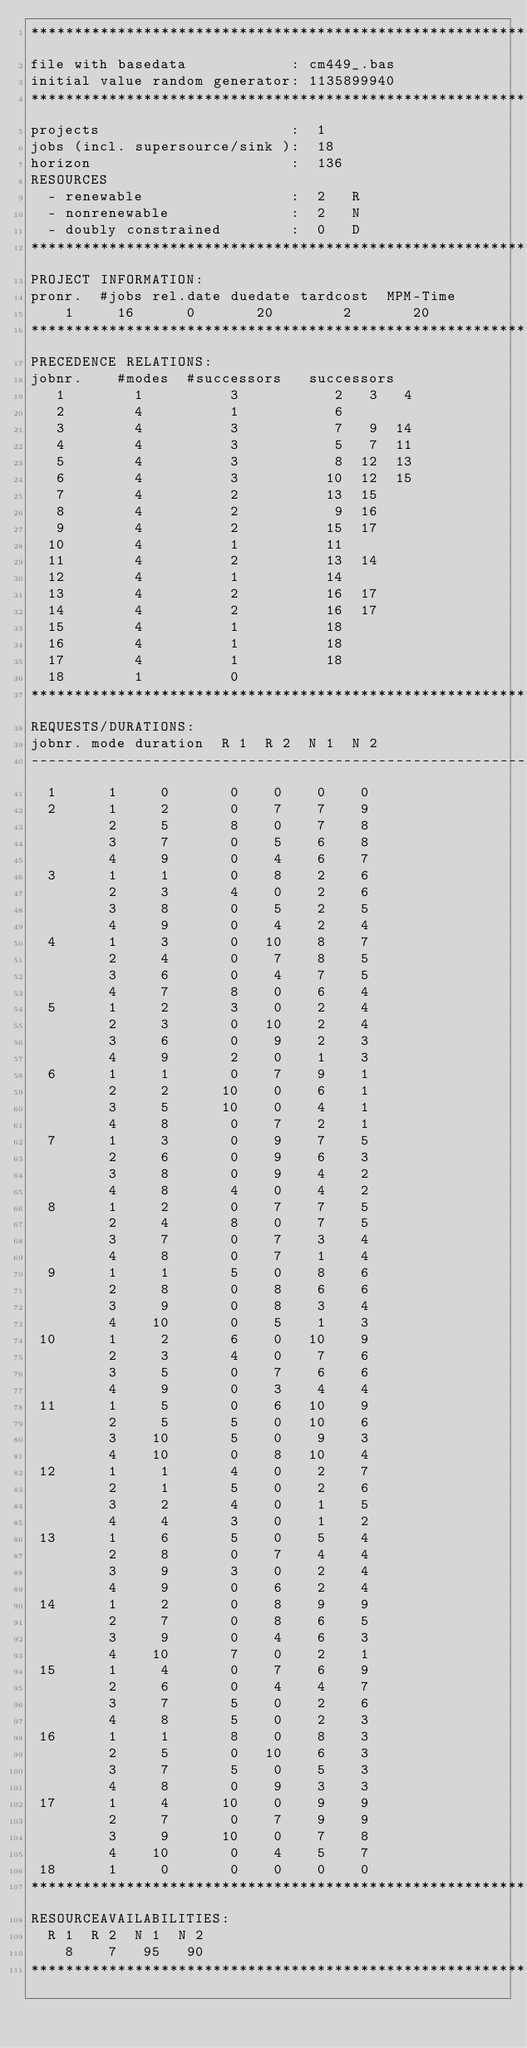Convert code to text. <code><loc_0><loc_0><loc_500><loc_500><_ObjectiveC_>************************************************************************
file with basedata            : cm449_.bas
initial value random generator: 1135899940
************************************************************************
projects                      :  1
jobs (incl. supersource/sink ):  18
horizon                       :  136
RESOURCES
  - renewable                 :  2   R
  - nonrenewable              :  2   N
  - doubly constrained        :  0   D
************************************************************************
PROJECT INFORMATION:
pronr.  #jobs rel.date duedate tardcost  MPM-Time
    1     16      0       20        2       20
************************************************************************
PRECEDENCE RELATIONS:
jobnr.    #modes  #successors   successors
   1        1          3           2   3   4
   2        4          1           6
   3        4          3           7   9  14
   4        4          3           5   7  11
   5        4          3           8  12  13
   6        4          3          10  12  15
   7        4          2          13  15
   8        4          2           9  16
   9        4          2          15  17
  10        4          1          11
  11        4          2          13  14
  12        4          1          14
  13        4          2          16  17
  14        4          2          16  17
  15        4          1          18
  16        4          1          18
  17        4          1          18
  18        1          0        
************************************************************************
REQUESTS/DURATIONS:
jobnr. mode duration  R 1  R 2  N 1  N 2
------------------------------------------------------------------------
  1      1     0       0    0    0    0
  2      1     2       0    7    7    9
         2     5       8    0    7    8
         3     7       0    5    6    8
         4     9       0    4    6    7
  3      1     1       0    8    2    6
         2     3       4    0    2    6
         3     8       0    5    2    5
         4     9       0    4    2    4
  4      1     3       0   10    8    7
         2     4       0    7    8    5
         3     6       0    4    7    5
         4     7       8    0    6    4
  5      1     2       3    0    2    4
         2     3       0   10    2    4
         3     6       0    9    2    3
         4     9       2    0    1    3
  6      1     1       0    7    9    1
         2     2      10    0    6    1
         3     5      10    0    4    1
         4     8       0    7    2    1
  7      1     3       0    9    7    5
         2     6       0    9    6    3
         3     8       0    9    4    2
         4     8       4    0    4    2
  8      1     2       0    7    7    5
         2     4       8    0    7    5
         3     7       0    7    3    4
         4     8       0    7    1    4
  9      1     1       5    0    8    6
         2     8       0    8    6    6
         3     9       0    8    3    4
         4    10       0    5    1    3
 10      1     2       6    0   10    9
         2     3       4    0    7    6
         3     5       0    7    6    6
         4     9       0    3    4    4
 11      1     5       0    6   10    9
         2     5       5    0   10    6
         3    10       5    0    9    3
         4    10       0    8   10    4
 12      1     1       4    0    2    7
         2     1       5    0    2    6
         3     2       4    0    1    5
         4     4       3    0    1    2
 13      1     6       5    0    5    4
         2     8       0    7    4    4
         3     9       3    0    2    4
         4     9       0    6    2    4
 14      1     2       0    8    9    9
         2     7       0    8    6    5
         3     9       0    4    6    3
         4    10       7    0    2    1
 15      1     4       0    7    6    9
         2     6       0    4    4    7
         3     7       5    0    2    6
         4     8       5    0    2    3
 16      1     1       8    0    8    3
         2     5       0   10    6    3
         3     7       5    0    5    3
         4     8       0    9    3    3
 17      1     4      10    0    9    9
         2     7       0    7    9    9
         3     9      10    0    7    8
         4    10       0    4    5    7
 18      1     0       0    0    0    0
************************************************************************
RESOURCEAVAILABILITIES:
  R 1  R 2  N 1  N 2
    8    7   95   90
************************************************************************
</code> 